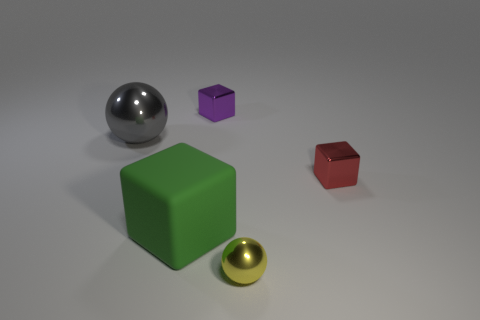Add 5 cyan metal cylinders. How many objects exist? 10 Subtract all balls. How many objects are left? 3 Add 3 small red cubes. How many small red cubes are left? 4 Add 4 large blocks. How many large blocks exist? 5 Subtract 0 blue cylinders. How many objects are left? 5 Subtract all small yellow metal balls. Subtract all large spheres. How many objects are left? 3 